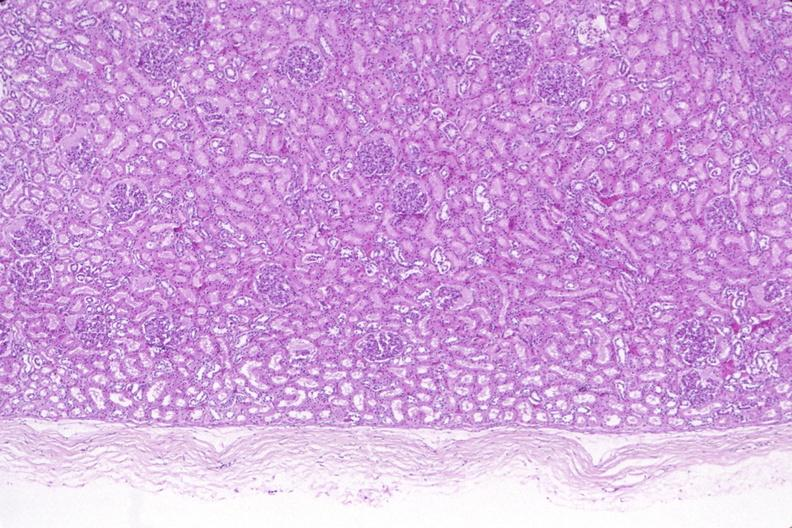does this image show kidney, normal histology?
Answer the question using a single word or phrase. Yes 